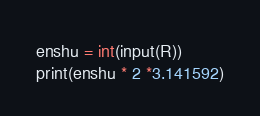Convert code to text. <code><loc_0><loc_0><loc_500><loc_500><_C_>enshu = int(input(R))
print(enshu * 2 *3.141592)

</code> 